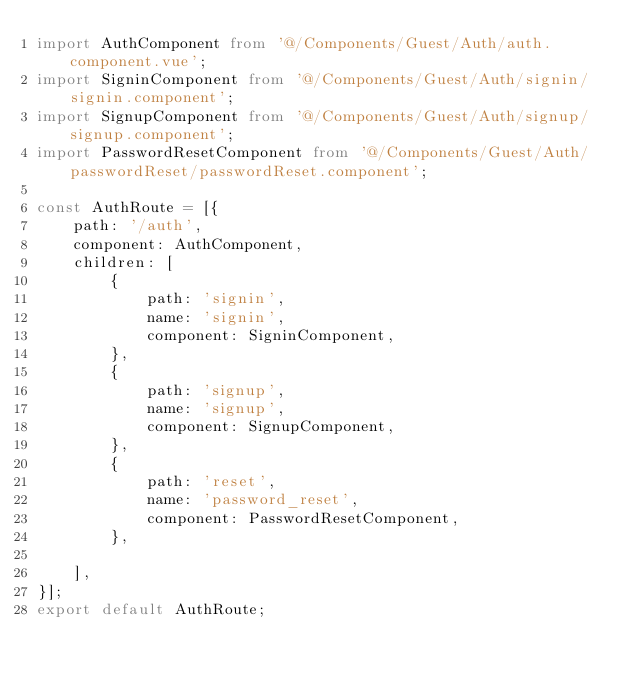Convert code to text. <code><loc_0><loc_0><loc_500><loc_500><_TypeScript_>import AuthComponent from '@/Components/Guest/Auth/auth.component.vue';
import SigninComponent from '@/Components/Guest/Auth/signin/signin.component';
import SignupComponent from '@/Components/Guest/Auth/signup/signup.component';
import PasswordResetComponent from '@/Components/Guest/Auth/passwordReset/passwordReset.component';

const AuthRoute = [{
    path: '/auth',
    component: AuthComponent,
    children: [
        {
            path: 'signin',
            name: 'signin',
            component: SigninComponent,
        },
        {
            path: 'signup',
            name: 'signup',
            component: SignupComponent,
        },
        {
            path: 'reset',
            name: 'password_reset',
            component: PasswordResetComponent,
        },

    ],
}];
export default AuthRoute;


</code> 